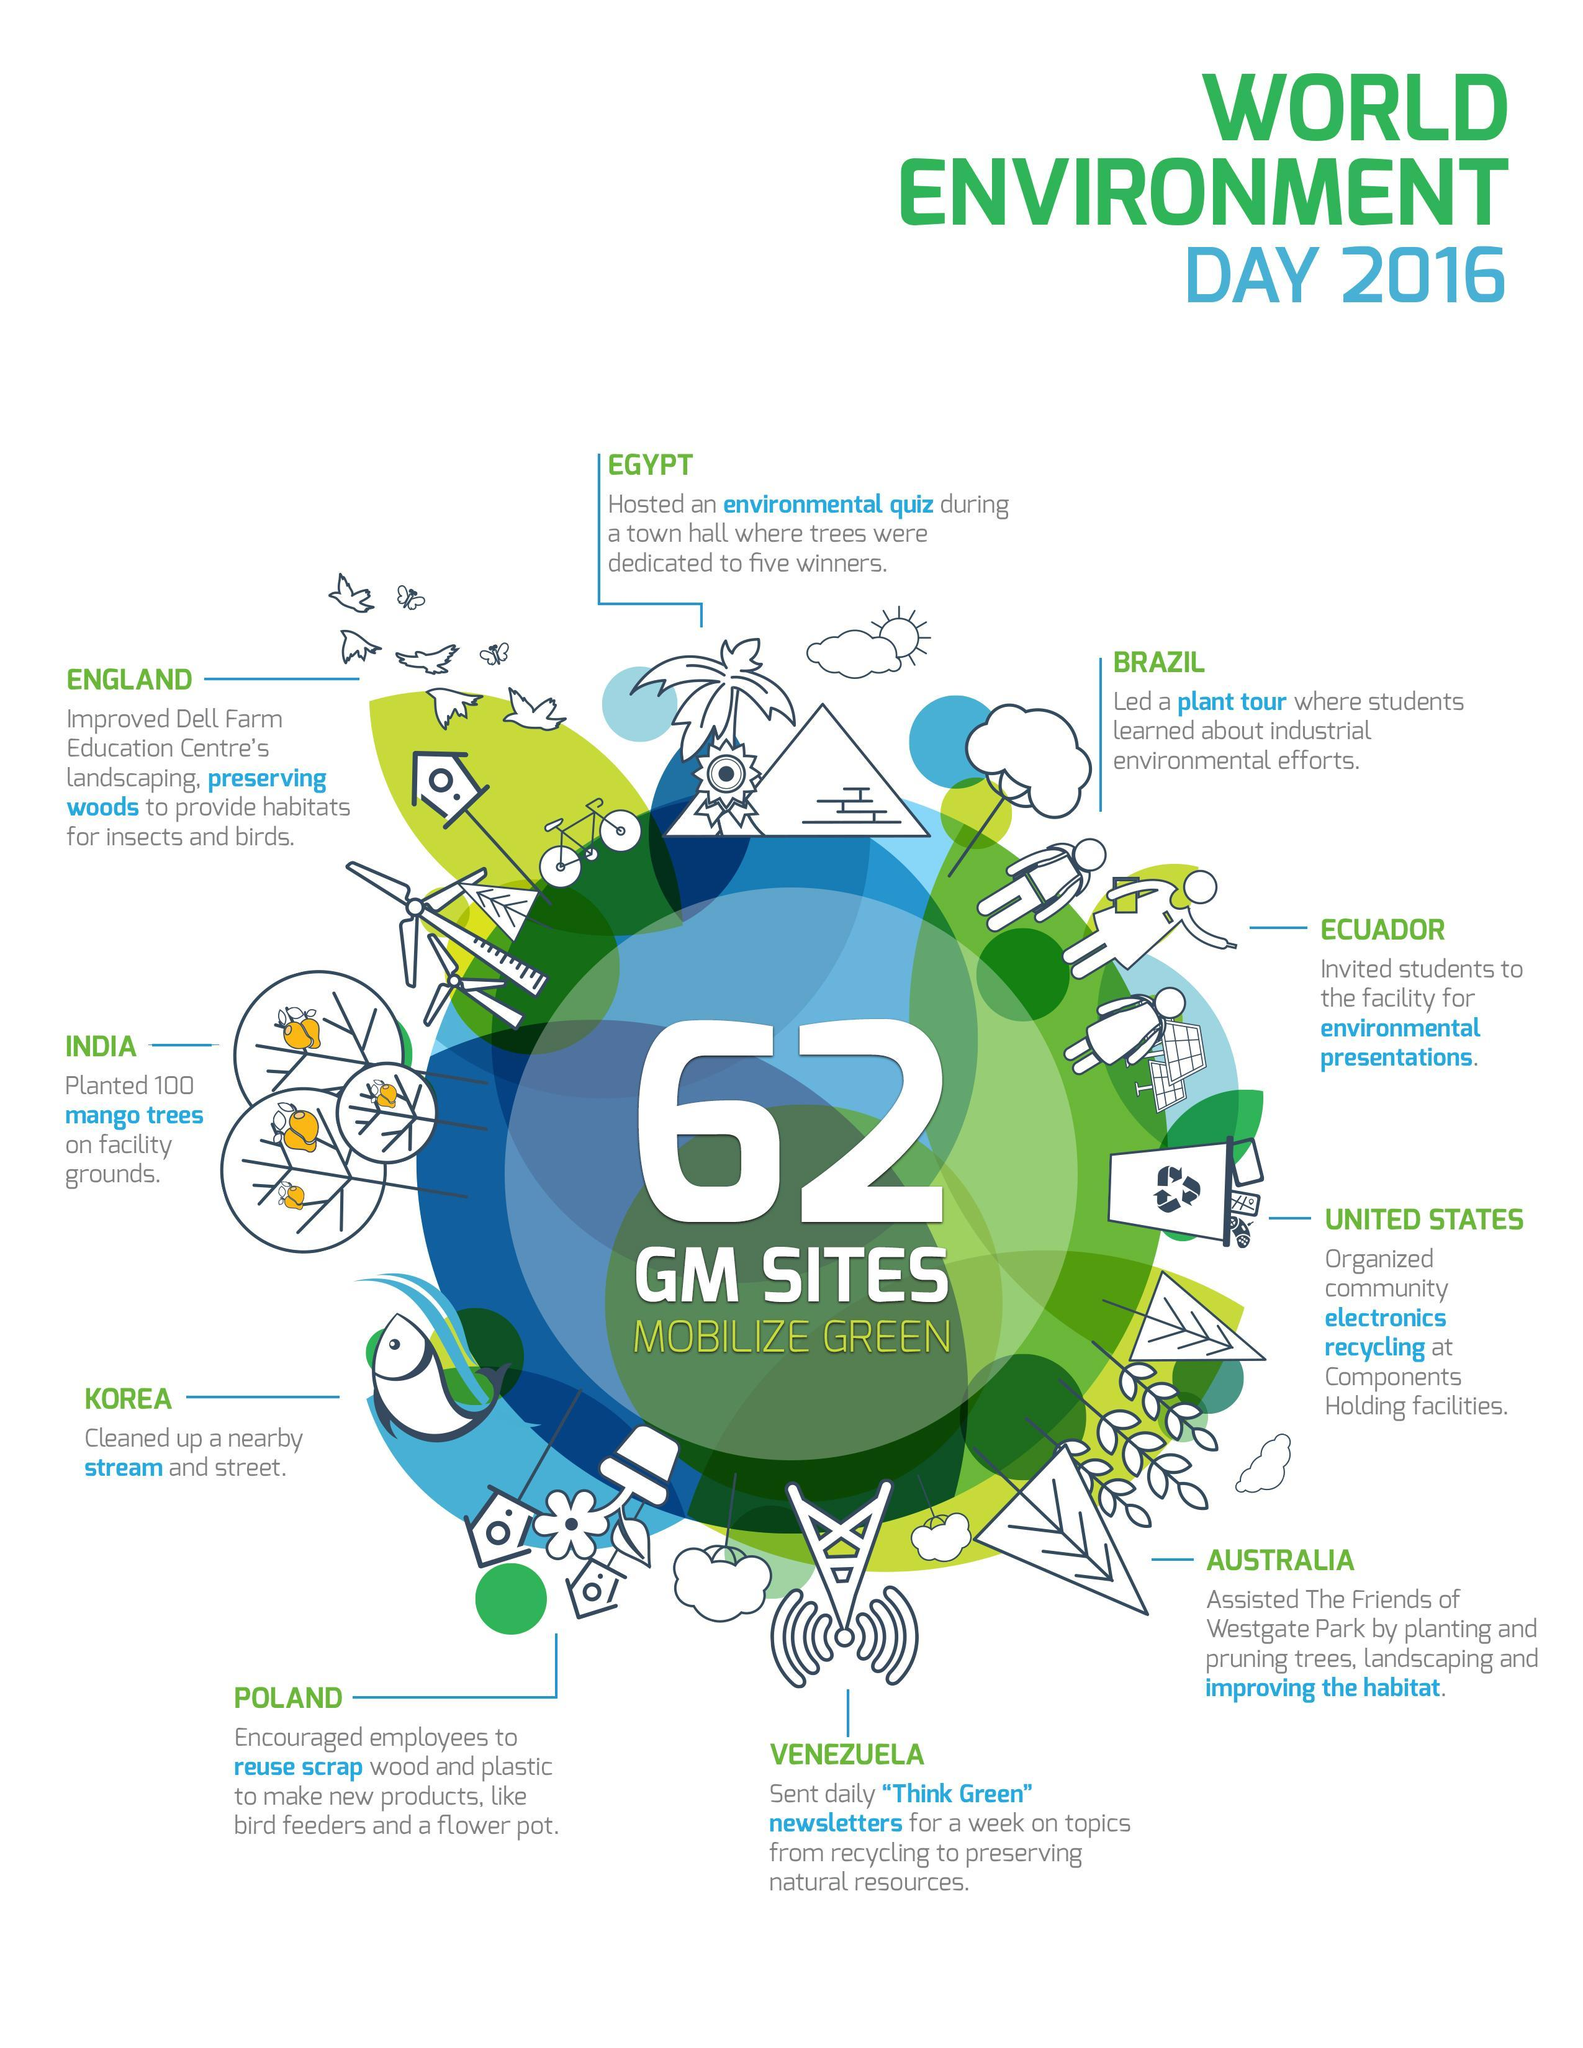Which country has planted 100 mango trees on facility ground for the World Environment Day 2016?
Answer the question with a short phrase. INDIA Which country cleaned up a nearby stream & street as a part of World Environment Day 2016? KOREA Which country led a plant tour for students as a part of World Environment Day 2016? BRAZIL 